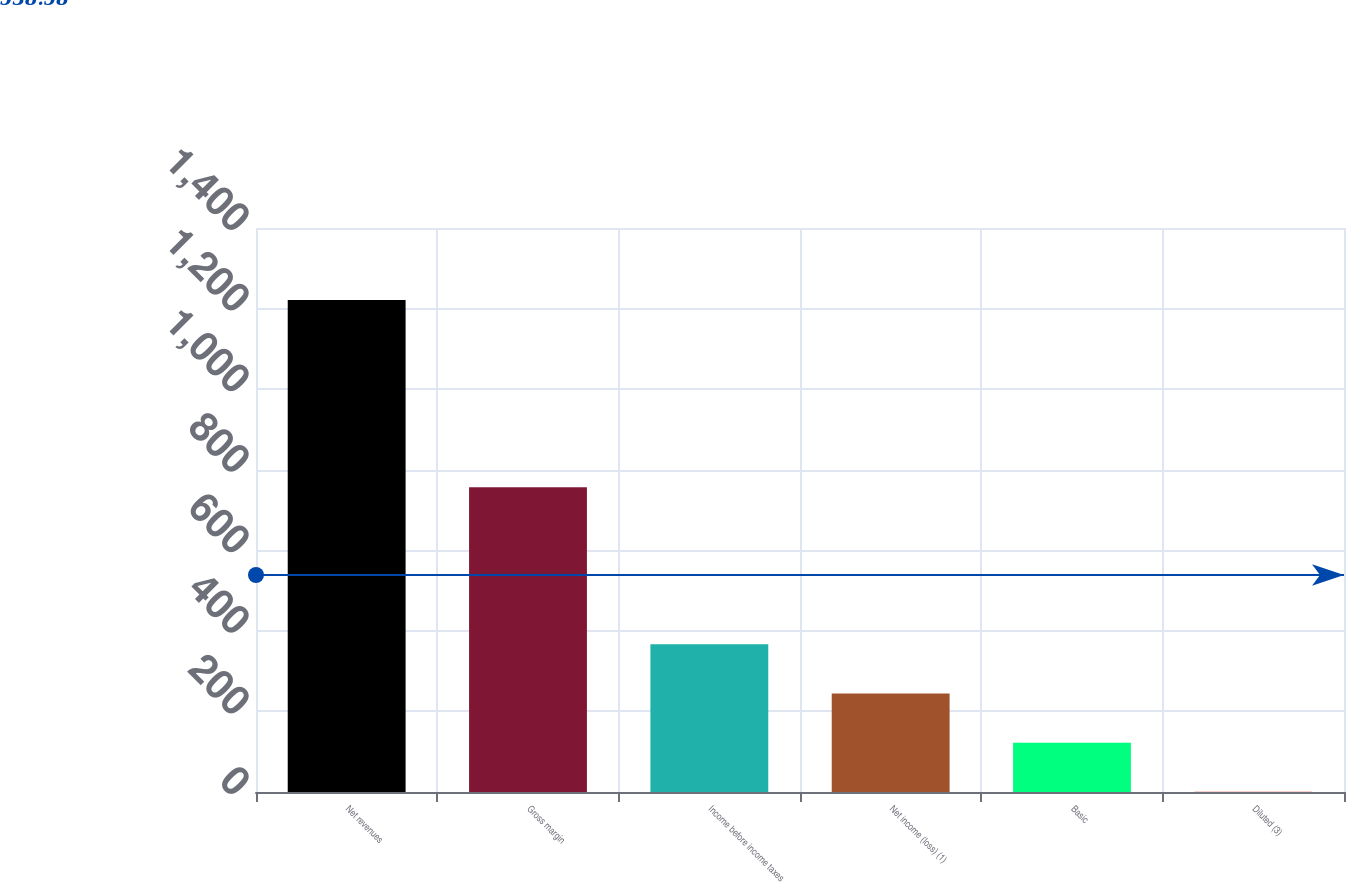Convert chart to OTSL. <chart><loc_0><loc_0><loc_500><loc_500><bar_chart><fcel>Net revenues<fcel>Gross margin<fcel>Income before income taxes<fcel>Net income (loss) (1)<fcel>Basic<fcel>Diluted (3)<nl><fcel>1221.3<fcel>756.4<fcel>366.63<fcel>244.54<fcel>122.45<fcel>0.36<nl></chart> 